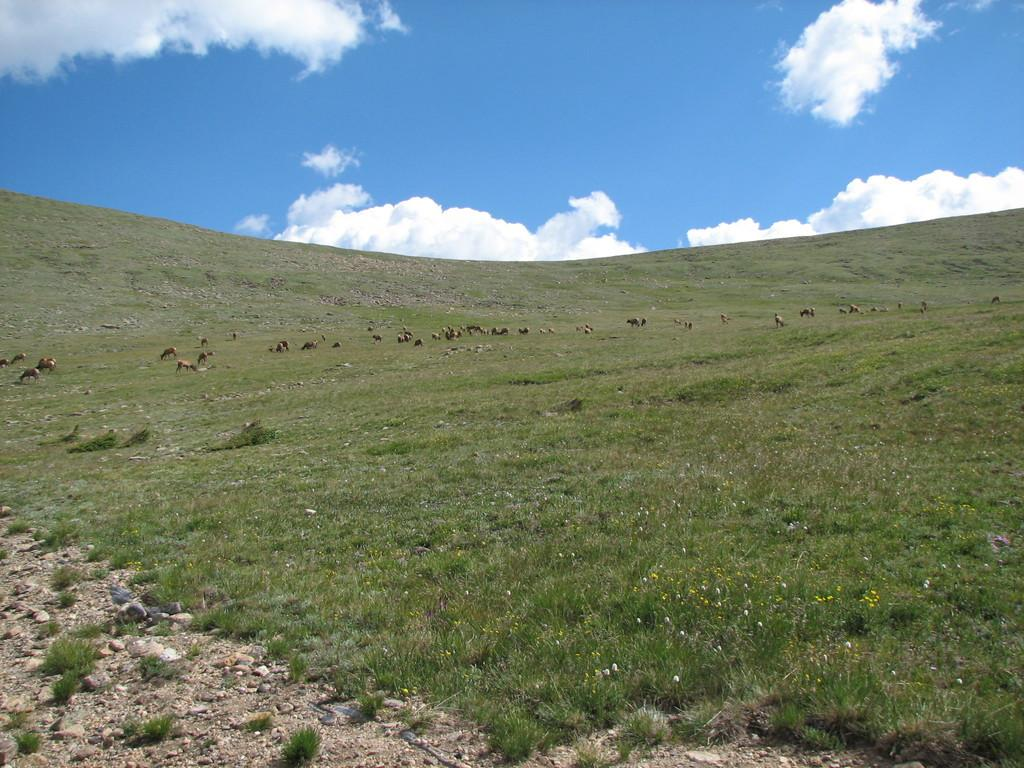What type of vegetation is on the ground in the image? There is grass on the ground in the image. What other natural elements can be seen in the image? There are small flowers in the image. Are there any living creatures in the image? Yes, there are animals in the image. What is visible at the top of the image? The sky is visible at the top of the image. What can be observed in the sky? Clouds are present in the sky. What type of polish is being applied to the animals in the image? There is no indication in the image that any polish is being applied to the animals. Is there a spy observing the animals in the image? There is no indication in the image of a spy or any human presence besides the animals. 